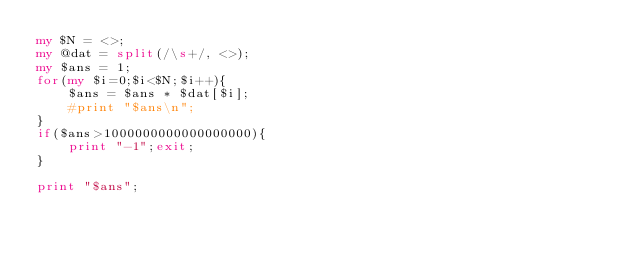Convert code to text. <code><loc_0><loc_0><loc_500><loc_500><_Perl_>my $N = <>;
my @dat = split(/\s+/, <>);
my $ans = 1;
for(my $i=0;$i<$N;$i++){
    $ans = $ans * $dat[$i];
    #print "$ans\n"; 
}
if($ans>1000000000000000000){
    print "-1";exit;
}

print "$ans";</code> 